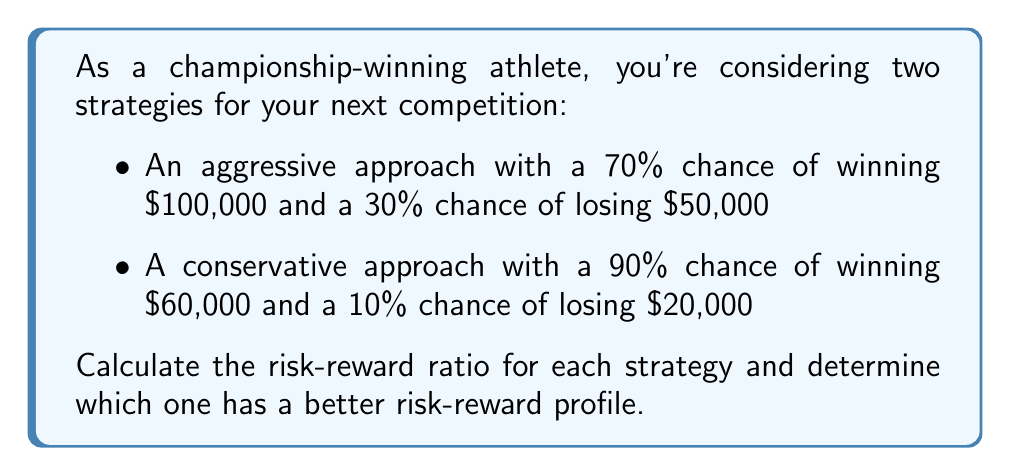Help me with this question. To solve this problem, we'll follow these steps:

1. Calculate the expected value (EV) for each strategy
2. Calculate the standard deviation (SD) for each strategy
3. Compute the risk-reward ratio (RRR) for each strategy
4. Compare the ratios to determine the better risk-reward profile

Step 1: Calculate the expected value (EV)

For the aggressive strategy:
$$EV_a = (0.70 \times 100,000) + (0.30 \times -50,000) = 55,000$$

For the conservative strategy:
$$EV_c = (0.90 \times 60,000) + (0.10 \times -20,000) = 52,000$$

Step 2: Calculate the standard deviation (SD)

For the aggressive strategy:
$$SD_a = \sqrt{(0.70 \times (100,000 - 55,000)^2) + (0.30 \times (-50,000 - 55,000)^2)} = 64,807.41$$

For the conservative strategy:
$$SD_c = \sqrt{(0.90 \times (60,000 - 52,000)^2) + (0.10 \times (-20,000 - 52,000)^2)} = 24,000$$

Step 3: Compute the risk-reward ratio (RRR)

The risk-reward ratio is calculated as the expected value divided by the standard deviation:

For the aggressive strategy:
$$RRR_a = \frac{EV_a}{SD_a} = \frac{55,000}{64,807.41} = 0.8487$$

For the conservative strategy:
$$RRR_c = \frac{EV_c}{SD_c} = \frac{52,000}{24,000} = 2.1667$$

Step 4: Compare the ratios

A higher risk-reward ratio indicates a better risk-reward profile. The conservative strategy has a higher ratio (2.1667) compared to the aggressive strategy (0.8487).
Answer: The risk-reward ratios are 0.8487 for the aggressive strategy and 2.1667 for the conservative strategy. The conservative strategy has a better risk-reward profile. 